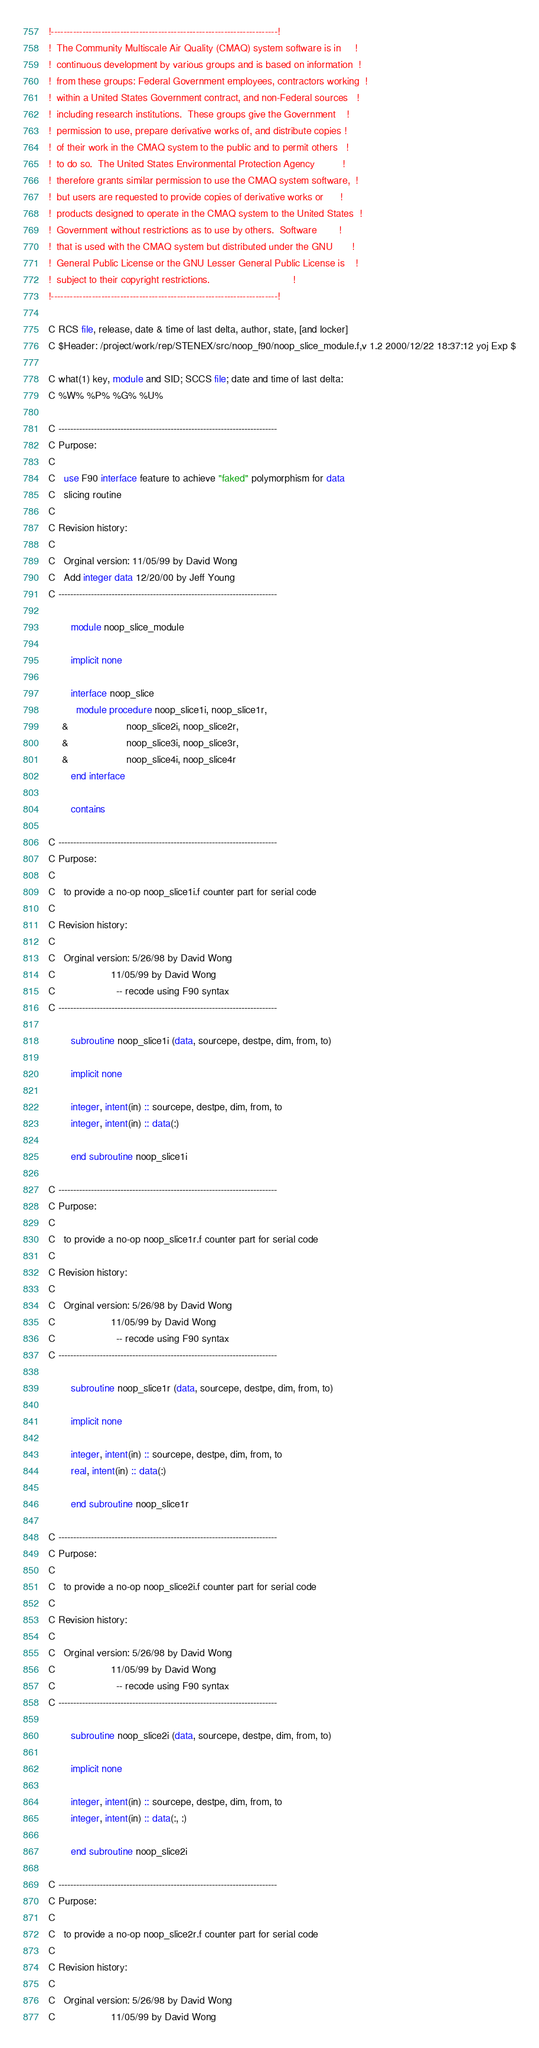Convert code to text. <code><loc_0><loc_0><loc_500><loc_500><_FORTRAN_>
!------------------------------------------------------------------------!
!  The Community Multiscale Air Quality (CMAQ) system software is in     !
!  continuous development by various groups and is based on information  !
!  from these groups: Federal Government employees, contractors working  !
!  within a United States Government contract, and non-Federal sources   !
!  including research institutions.  These groups give the Government    !
!  permission to use, prepare derivative works of, and distribute copies !
!  of their work in the CMAQ system to the public and to permit others   !
!  to do so.  The United States Environmental Protection Agency          !
!  therefore grants similar permission to use the CMAQ system software,  !
!  but users are requested to provide copies of derivative works or      !
!  products designed to operate in the CMAQ system to the United States  !
!  Government without restrictions as to use by others.  Software        !
!  that is used with the CMAQ system but distributed under the GNU       !
!  General Public License or the GNU Lesser General Public License is    !
!  subject to their copyright restrictions.                              !
!------------------------------------------------------------------------!

C RCS file, release, date & time of last delta, author, state, [and locker]
C $Header: /project/work/rep/STENEX/src/noop_f90/noop_slice_module.f,v 1.2 2000/12/22 18:37:12 yoj Exp $

C what(1) key, module and SID; SCCS file; date and time of last delta:
C %W% %P% %G% %U%

C --------------------------------------------------------------------------
C Purpose:
C
C   use F90 interface feature to achieve "faked" polymorphism for data
C   slicing routine
C
C Revision history:
C
C   Orginal version: 11/05/99 by David Wong
C   Add integer data 12/20/00 by Jeff Young
C --------------------------------------------------------------------------

        module noop_slice_module

        implicit none

        interface noop_slice
          module procedure noop_slice1i, noop_slice1r,
     &                     noop_slice2i, noop_slice2r,
     &                     noop_slice3i, noop_slice3r,
     &                     noop_slice4i, noop_slice4r
        end interface

        contains

C --------------------------------------------------------------------------
C Purpose:
C
C   to provide a no-op noop_slice1i.f counter part for serial code
C
C Revision history:
C
C   Orginal version: 5/26/98 by David Wong
C                    11/05/99 by David Wong
C                      -- recode using F90 syntax
C --------------------------------------------------------------------------

        subroutine noop_slice1i (data, sourcepe, destpe, dim, from, to)

        implicit none

        integer, intent(in) :: sourcepe, destpe, dim, from, to
        integer, intent(in) :: data(:)

        end subroutine noop_slice1i 

C --------------------------------------------------------------------------
C Purpose:
C
C   to provide a no-op noop_slice1r.f counter part for serial code
C
C Revision history:
C
C   Orginal version: 5/26/98 by David Wong
C                    11/05/99 by David Wong
C                      -- recode using F90 syntax
C --------------------------------------------------------------------------

        subroutine noop_slice1r (data, sourcepe, destpe, dim, from, to)

        implicit none

        integer, intent(in) :: sourcepe, destpe, dim, from, to
        real, intent(in) :: data(:)

        end subroutine noop_slice1r 

C --------------------------------------------------------------------------
C Purpose:
C
C   to provide a no-op noop_slice2i.f counter part for serial code
C
C Revision history:
C
C   Orginal version: 5/26/98 by David Wong
C                    11/05/99 by David Wong
C                      -- recode using F90 syntax
C --------------------------------------------------------------------------

        subroutine noop_slice2i (data, sourcepe, destpe, dim, from, to)

        implicit none

        integer, intent(in) :: sourcepe, destpe, dim, from, to
        integer, intent(in) :: data(:, :)

        end subroutine noop_slice2i 

C --------------------------------------------------------------------------
C Purpose:
C
C   to provide a no-op noop_slice2r.f counter part for serial code
C
C Revision history:
C
C   Orginal version: 5/26/98 by David Wong
C                    11/05/99 by David Wong</code> 